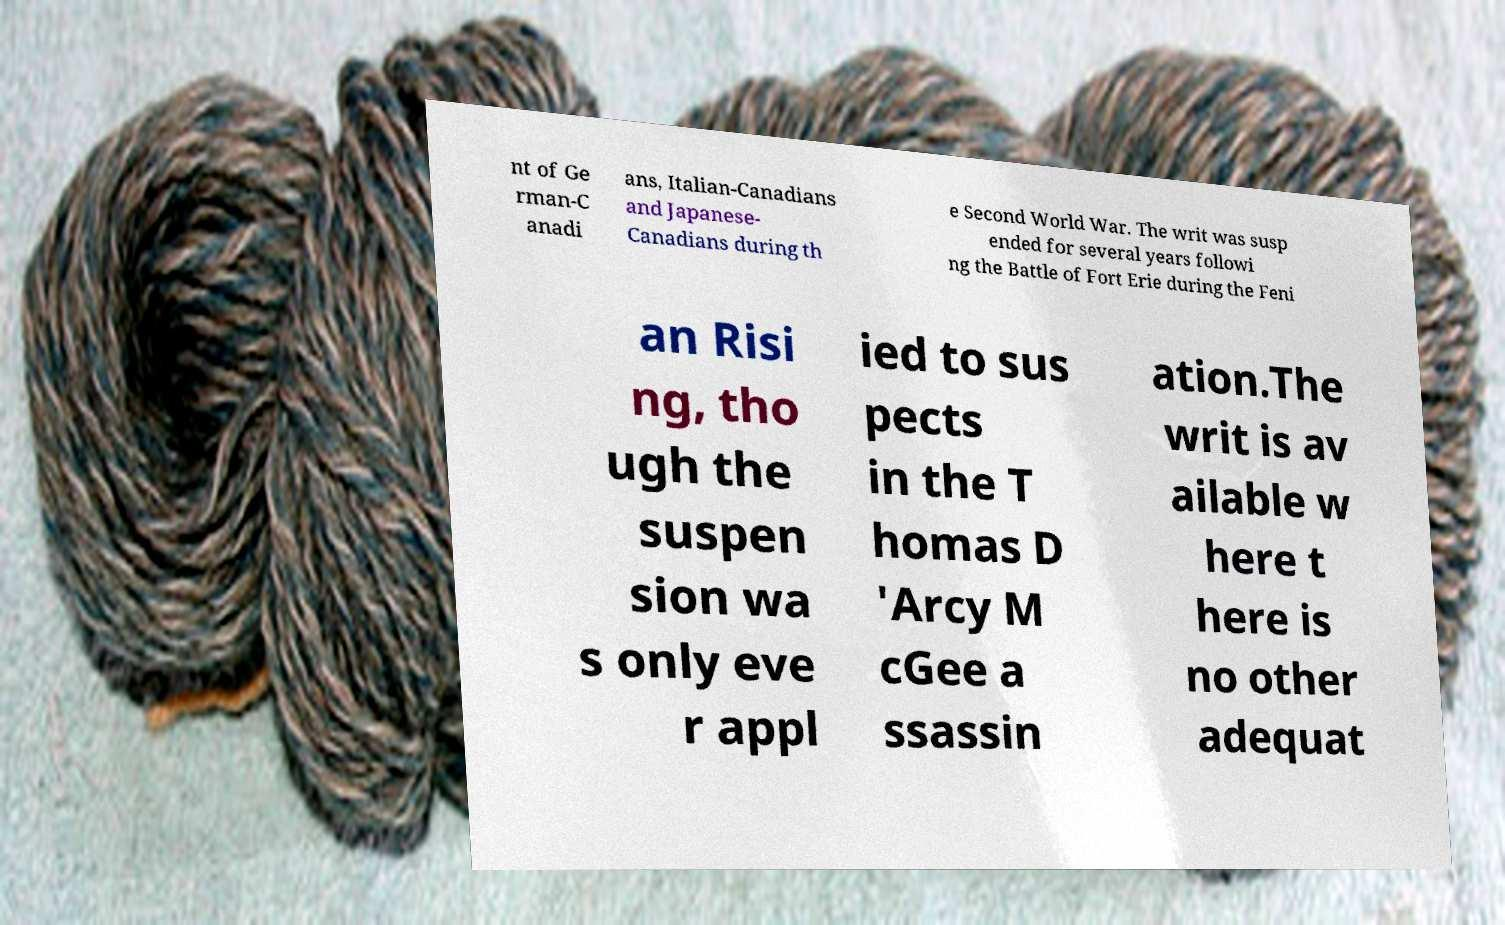Please identify and transcribe the text found in this image. nt of Ge rman-C anadi ans, Italian-Canadians and Japanese- Canadians during th e Second World War. The writ was susp ended for several years followi ng the Battle of Fort Erie during the Feni an Risi ng, tho ugh the suspen sion wa s only eve r appl ied to sus pects in the T homas D 'Arcy M cGee a ssassin ation.The writ is av ailable w here t here is no other adequat 